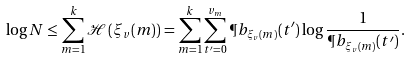<formula> <loc_0><loc_0><loc_500><loc_500>\log { N } \leq \sum _ { m = 1 } ^ { k } \mathcal { H } \left ( \xi _ { v } ( m ) \right ) = \sum _ { m = 1 } ^ { k } \sum _ { t ^ { \prime } = 0 } ^ { v _ { m } } \P b _ { \xi _ { v } ( m ) } ( t ^ { \prime } ) \log { \frac { 1 } { \P b _ { \xi _ { v } ( m ) } ( t ^ { \prime } ) } } .</formula> 